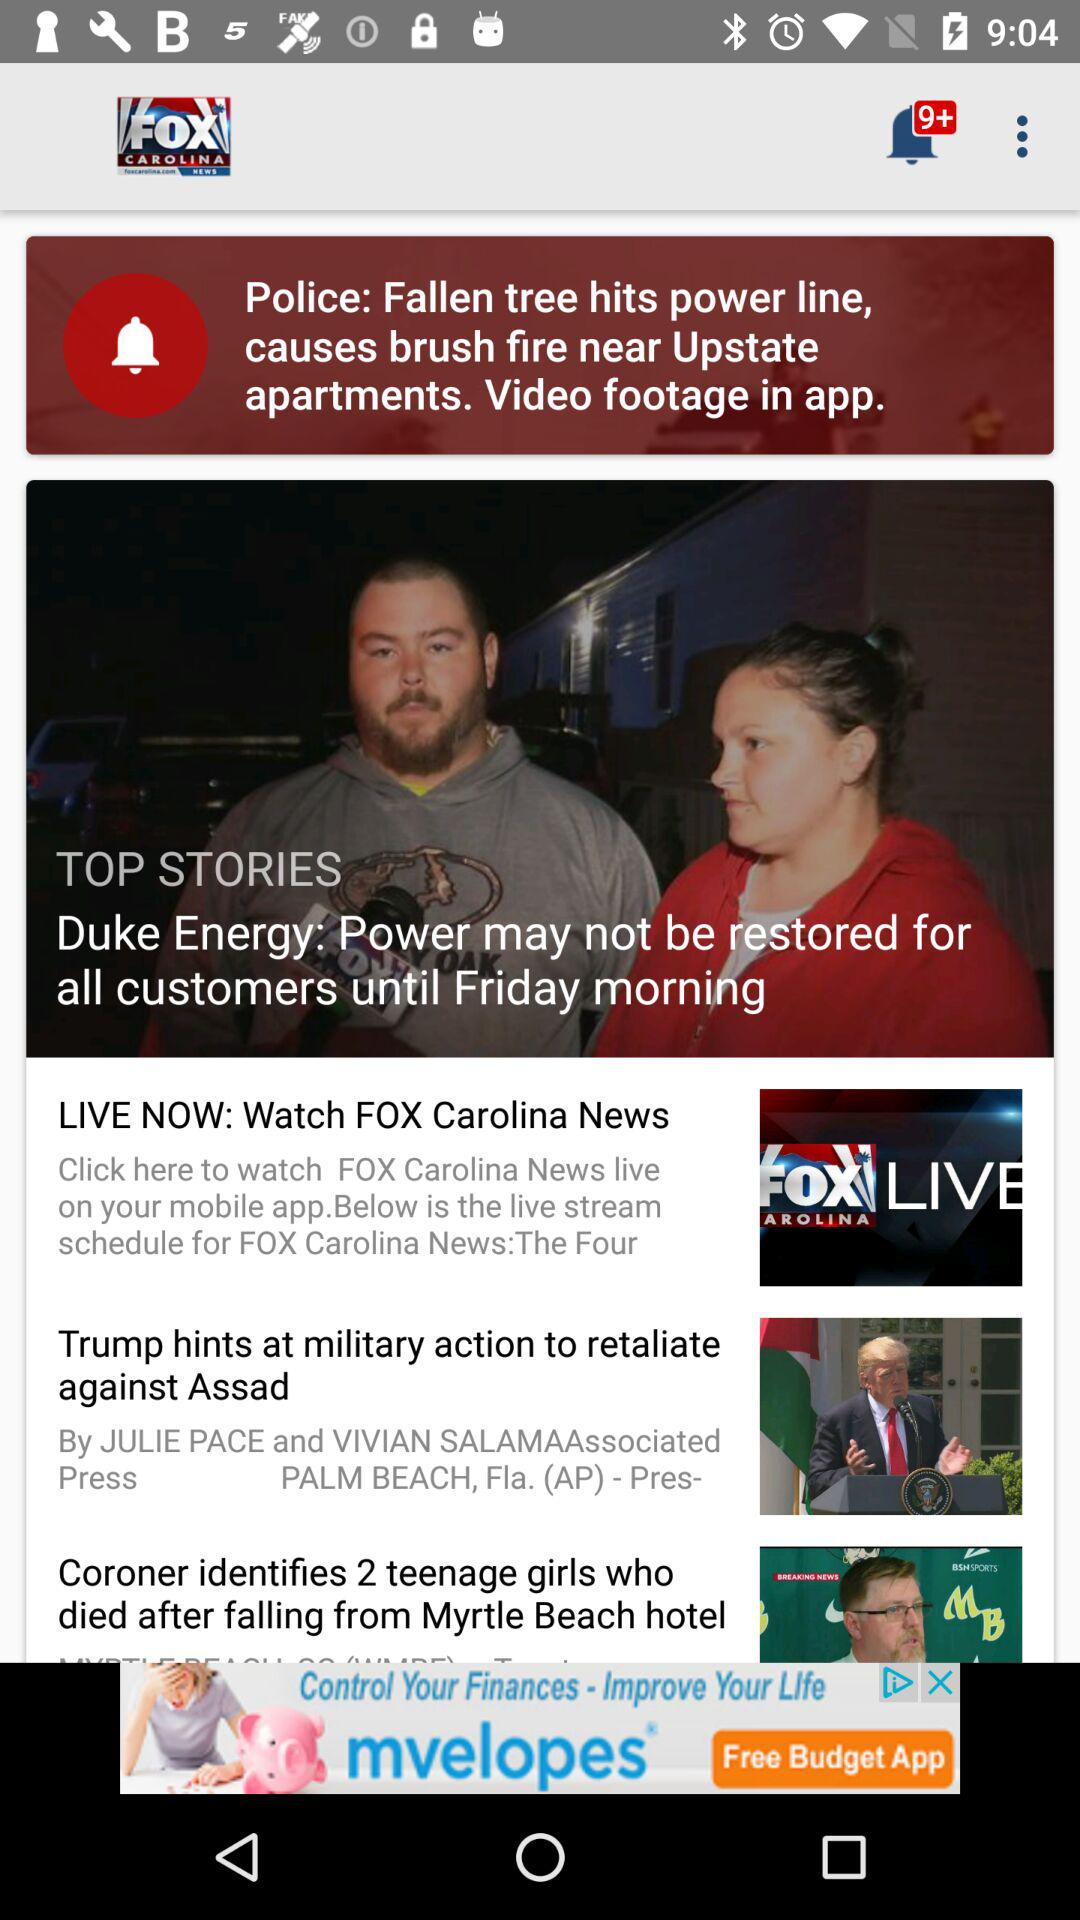Who posted the story "Trump hints at military action to retaliate against Assad"? The story "Trump hints at military action to retaliate against Assad" was posted by "Associated Press". 